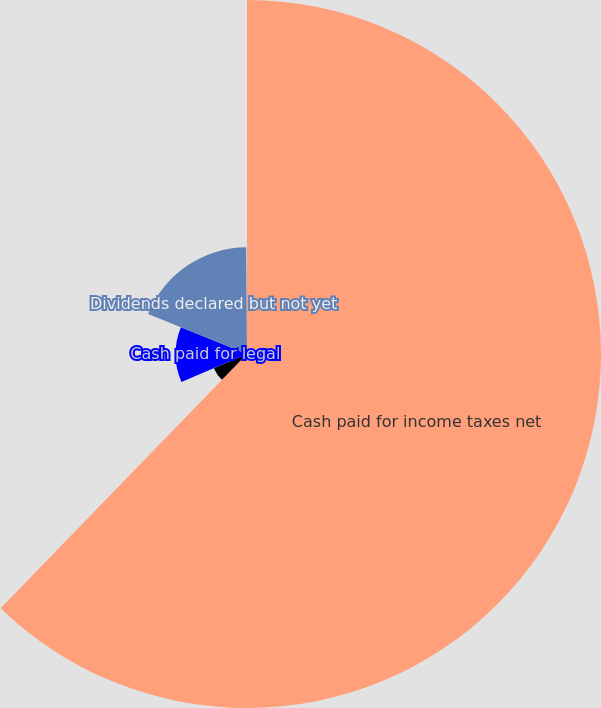Convert chart. <chart><loc_0><loc_0><loc_500><loc_500><pie_chart><fcel>Cash paid for income taxes net<fcel>Cash paid for interest<fcel>Cash paid for legal<fcel>Dividends declared but not yet<fcel>Capital leases and other<nl><fcel>62.25%<fcel>6.33%<fcel>12.54%<fcel>18.76%<fcel>0.12%<nl></chart> 